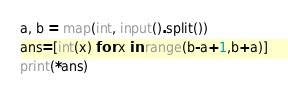Convert code to text. <code><loc_0><loc_0><loc_500><loc_500><_Python_>a, b = map(int, input().split())
ans=[int(x) for x in range(b-a+1,b+a)]
print(*ans)</code> 